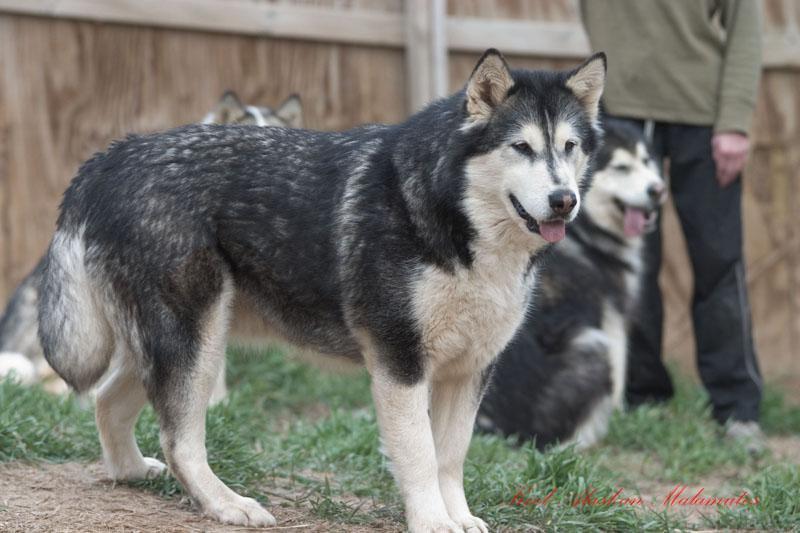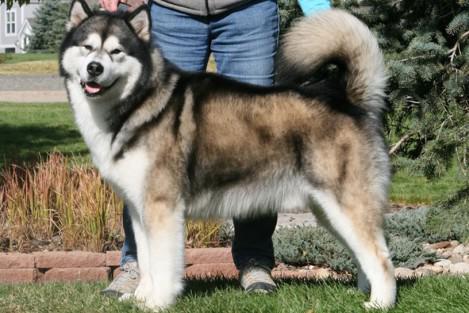The first image is the image on the left, the second image is the image on the right. For the images displayed, is the sentence "There is at least one person visible behind a dog." factually correct? Answer yes or no. Yes. 